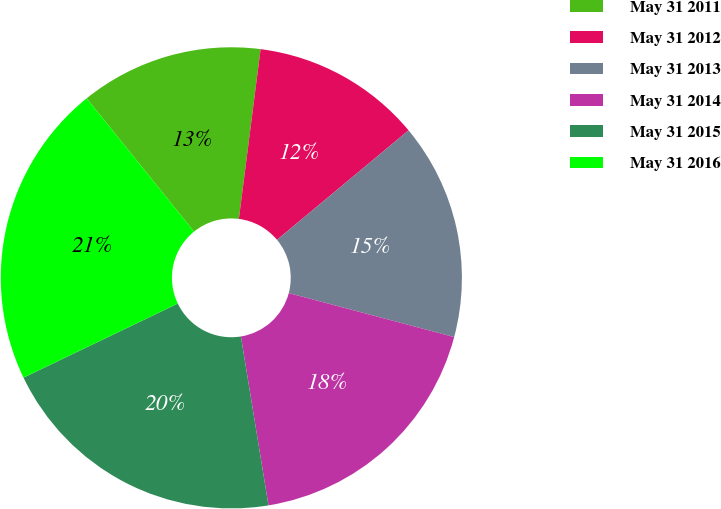<chart> <loc_0><loc_0><loc_500><loc_500><pie_chart><fcel>May 31 2011<fcel>May 31 2012<fcel>May 31 2013<fcel>May 31 2014<fcel>May 31 2015<fcel>May 31 2016<nl><fcel>12.82%<fcel>11.93%<fcel>15.18%<fcel>18.29%<fcel>20.45%<fcel>21.33%<nl></chart> 